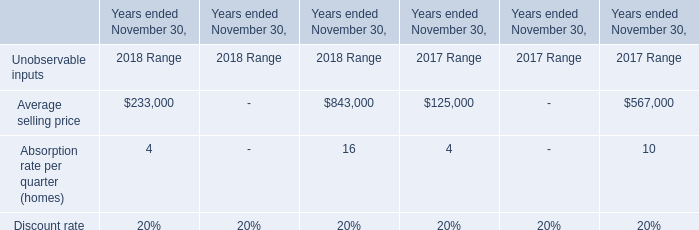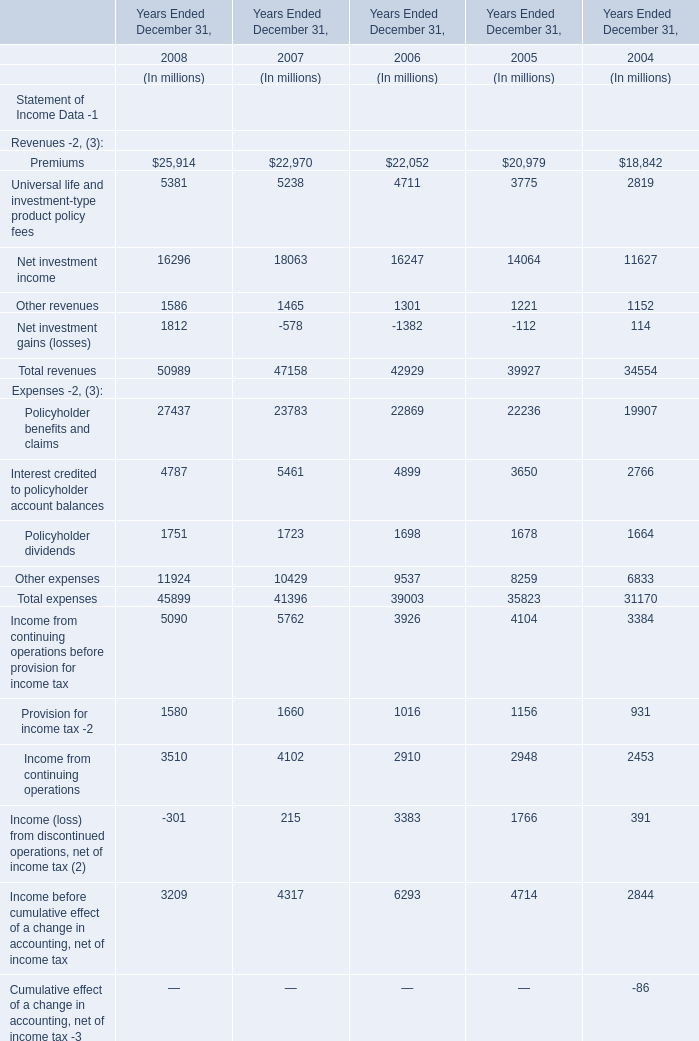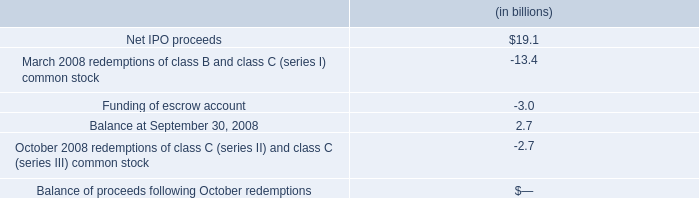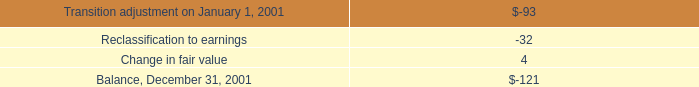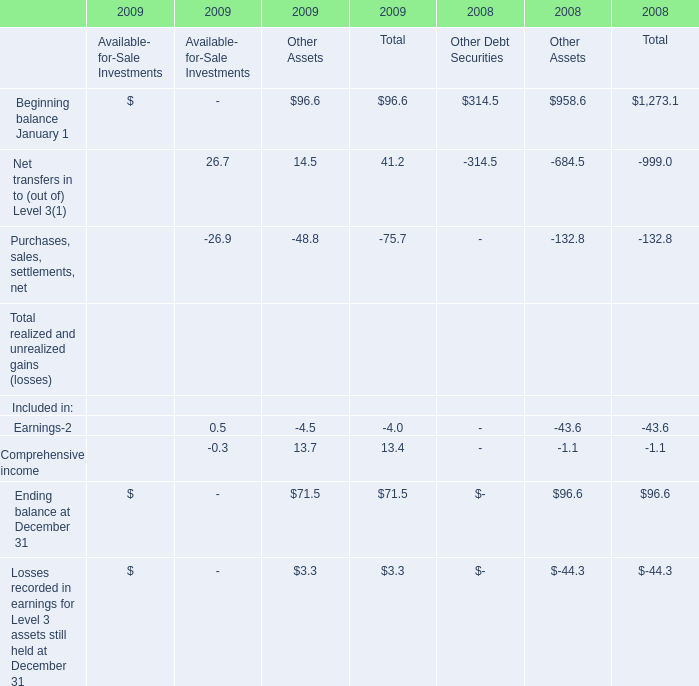what portion of the ipo net proceeds was used for redemptions of class b and class c ( series i ) common stock on march 2008? 
Computations: (13.4 / 19.1)
Answer: 0.70157. 